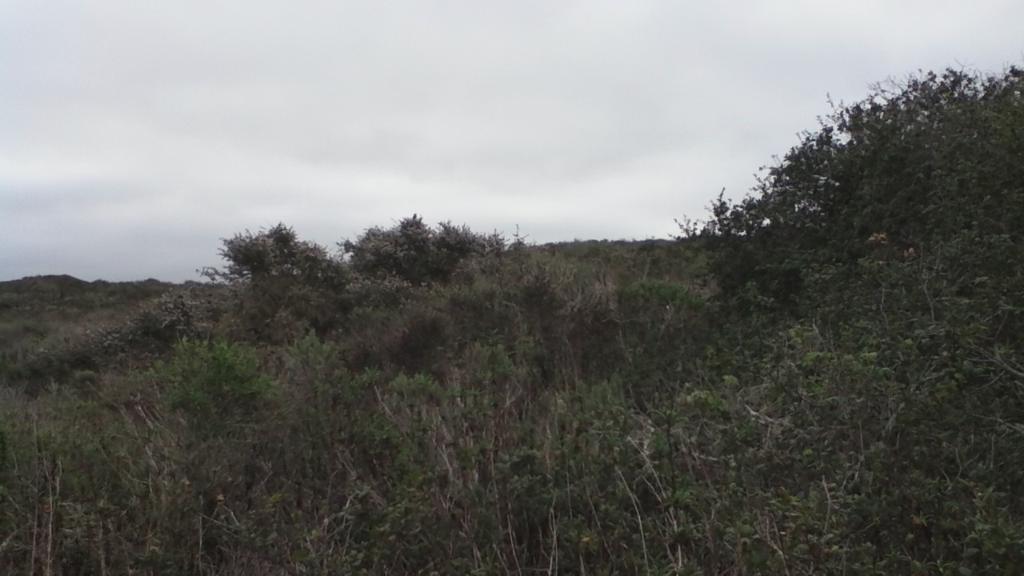How would you summarize this image in a sentence or two? In this picture I can see trees, and in the background there is the sky. 